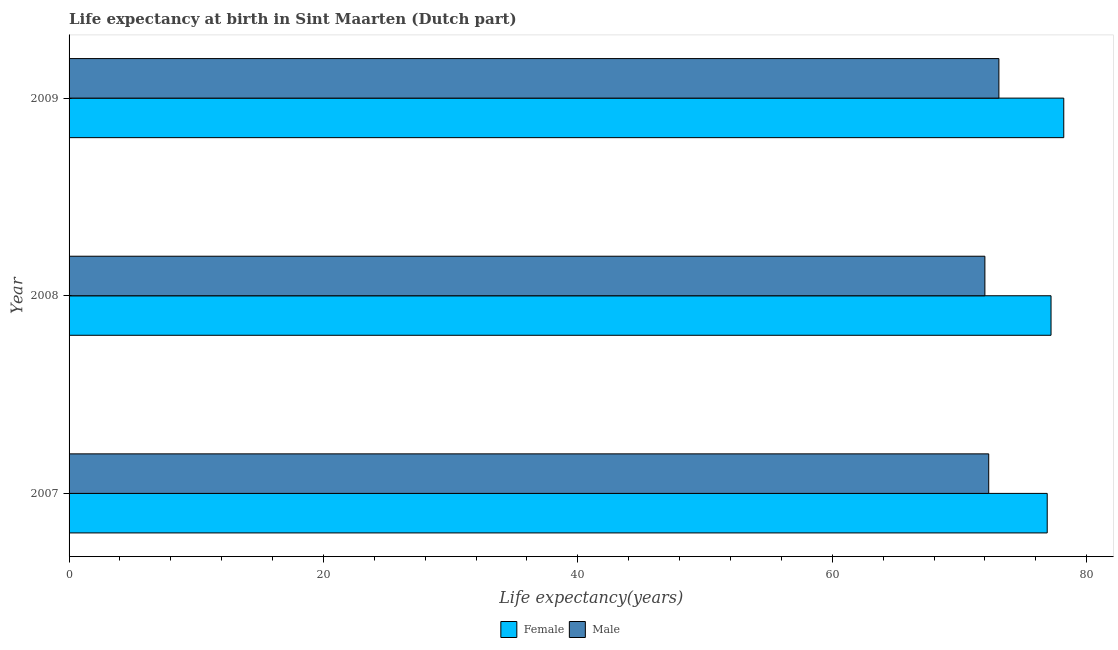How many different coloured bars are there?
Provide a succinct answer. 2. Are the number of bars per tick equal to the number of legend labels?
Give a very brief answer. Yes. Are the number of bars on each tick of the Y-axis equal?
Provide a short and direct response. Yes. How many bars are there on the 2nd tick from the bottom?
Your response must be concise. 2. What is the life expectancy(male) in 2007?
Keep it short and to the point. 72.3. Across all years, what is the maximum life expectancy(female)?
Keep it short and to the point. 78.2. What is the total life expectancy(male) in the graph?
Keep it short and to the point. 217.4. What is the difference between the life expectancy(female) in 2009 and the life expectancy(male) in 2007?
Give a very brief answer. 5.9. What is the average life expectancy(male) per year?
Ensure brevity in your answer.  72.47. In the year 2009, what is the difference between the life expectancy(female) and life expectancy(male)?
Give a very brief answer. 5.1. Is the difference between the life expectancy(female) in 2007 and 2009 greater than the difference between the life expectancy(male) in 2007 and 2009?
Give a very brief answer. No. What is the difference between the highest and the lowest life expectancy(male)?
Give a very brief answer. 1.1. In how many years, is the life expectancy(male) greater than the average life expectancy(male) taken over all years?
Offer a very short reply. 1. What does the 1st bar from the top in 2008 represents?
Your answer should be very brief. Male. Are all the bars in the graph horizontal?
Your answer should be very brief. Yes. Are the values on the major ticks of X-axis written in scientific E-notation?
Your answer should be compact. No. How many legend labels are there?
Offer a very short reply. 2. How are the legend labels stacked?
Offer a terse response. Horizontal. What is the title of the graph?
Provide a short and direct response. Life expectancy at birth in Sint Maarten (Dutch part). Does "Young" appear as one of the legend labels in the graph?
Provide a succinct answer. No. What is the label or title of the X-axis?
Keep it short and to the point. Life expectancy(years). What is the Life expectancy(years) in Female in 2007?
Your answer should be compact. 76.9. What is the Life expectancy(years) in Male in 2007?
Your answer should be compact. 72.3. What is the Life expectancy(years) in Female in 2008?
Give a very brief answer. 77.2. What is the Life expectancy(years) in Female in 2009?
Your answer should be very brief. 78.2. What is the Life expectancy(years) of Male in 2009?
Your response must be concise. 73.1. Across all years, what is the maximum Life expectancy(years) in Female?
Make the answer very short. 78.2. Across all years, what is the maximum Life expectancy(years) in Male?
Your answer should be very brief. 73.1. Across all years, what is the minimum Life expectancy(years) of Female?
Provide a succinct answer. 76.9. Across all years, what is the minimum Life expectancy(years) of Male?
Offer a very short reply. 72. What is the total Life expectancy(years) in Female in the graph?
Ensure brevity in your answer.  232.3. What is the total Life expectancy(years) of Male in the graph?
Make the answer very short. 217.4. What is the difference between the Life expectancy(years) in Female in 2007 and that in 2008?
Keep it short and to the point. -0.3. What is the difference between the Life expectancy(years) of Female in 2007 and that in 2009?
Your answer should be compact. -1.3. What is the difference between the Life expectancy(years) in Male in 2007 and that in 2009?
Keep it short and to the point. -0.8. What is the difference between the Life expectancy(years) in Female in 2008 and the Life expectancy(years) in Male in 2009?
Your response must be concise. 4.1. What is the average Life expectancy(years) of Female per year?
Provide a succinct answer. 77.43. What is the average Life expectancy(years) in Male per year?
Offer a very short reply. 72.47. In the year 2007, what is the difference between the Life expectancy(years) of Female and Life expectancy(years) of Male?
Keep it short and to the point. 4.6. In the year 2009, what is the difference between the Life expectancy(years) in Female and Life expectancy(years) in Male?
Offer a terse response. 5.1. What is the ratio of the Life expectancy(years) of Female in 2007 to that in 2008?
Provide a succinct answer. 1. What is the ratio of the Life expectancy(years) of Female in 2007 to that in 2009?
Your answer should be very brief. 0.98. What is the ratio of the Life expectancy(years) of Female in 2008 to that in 2009?
Your response must be concise. 0.99. What is the difference between the highest and the lowest Life expectancy(years) in Female?
Your answer should be very brief. 1.3. 